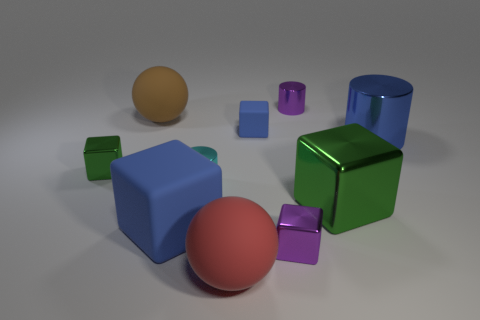Subtract all purple cubes. How many cubes are left? 4 Subtract all large metal blocks. How many blocks are left? 4 Subtract all yellow cubes. Subtract all red cylinders. How many cubes are left? 5 Subtract all balls. How many objects are left? 8 Add 1 tiny matte cubes. How many tiny matte cubes are left? 2 Add 7 cyan objects. How many cyan objects exist? 8 Subtract 0 purple spheres. How many objects are left? 10 Subtract all big spheres. Subtract all big red spheres. How many objects are left? 7 